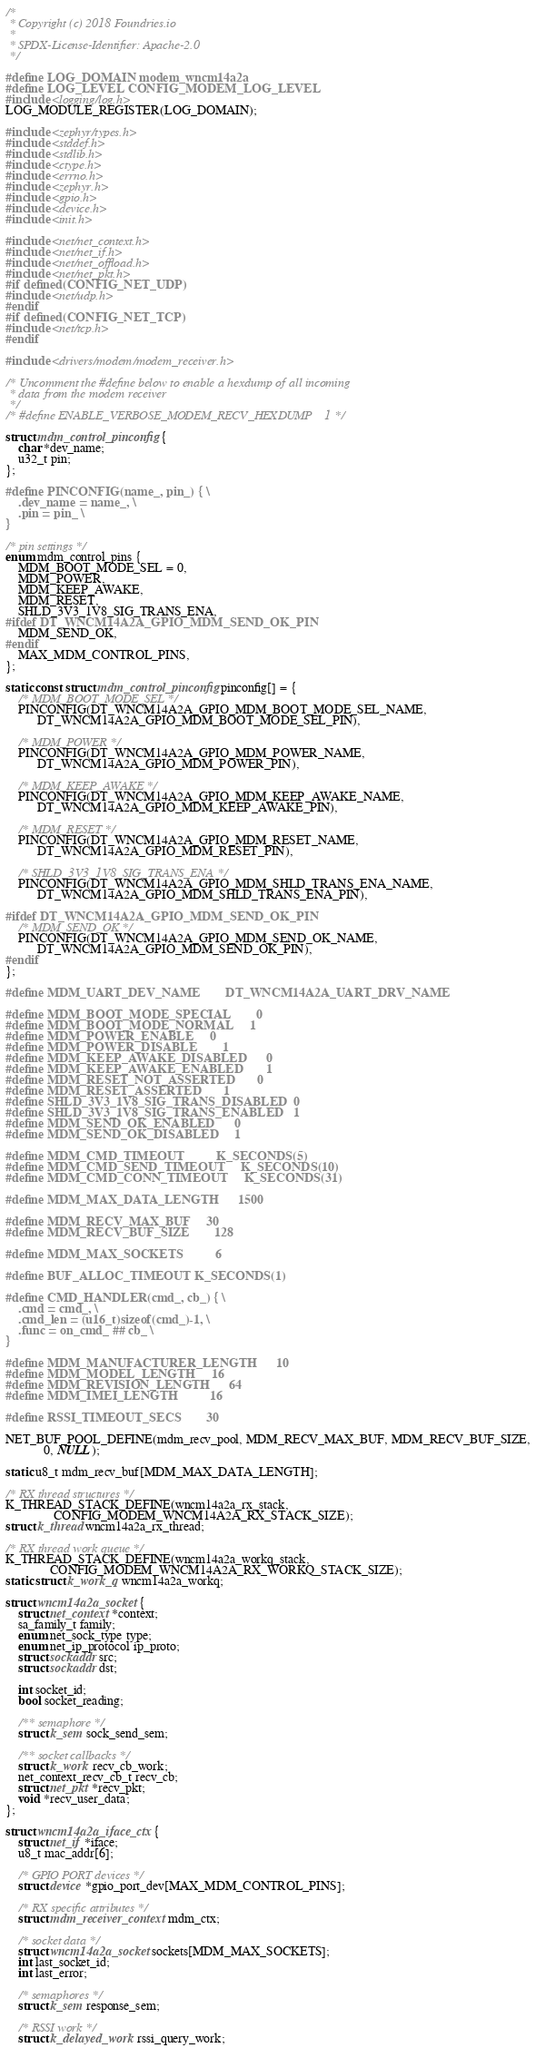Convert code to text. <code><loc_0><loc_0><loc_500><loc_500><_C_>/*
 * Copyright (c) 2018 Foundries.io
 *
 * SPDX-License-Identifier: Apache-2.0
 */

#define LOG_DOMAIN modem_wncm14a2a
#define LOG_LEVEL CONFIG_MODEM_LOG_LEVEL
#include <logging/log.h>
LOG_MODULE_REGISTER(LOG_DOMAIN);

#include <zephyr/types.h>
#include <stddef.h>
#include <stdlib.h>
#include <ctype.h>
#include <errno.h>
#include <zephyr.h>
#include <gpio.h>
#include <device.h>
#include <init.h>

#include <net/net_context.h>
#include <net/net_if.h>
#include <net/net_offload.h>
#include <net/net_pkt.h>
#if defined(CONFIG_NET_UDP)
#include <net/udp.h>
#endif
#if defined(CONFIG_NET_TCP)
#include <net/tcp.h>
#endif

#include <drivers/modem/modem_receiver.h>

/* Uncomment the #define below to enable a hexdump of all incoming
 * data from the modem receiver
 */
/* #define ENABLE_VERBOSE_MODEM_RECV_HEXDUMP	1 */

struct mdm_control_pinconfig {
	char *dev_name;
	u32_t pin;
};

#define PINCONFIG(name_, pin_) { \
	.dev_name = name_, \
	.pin = pin_ \
}

/* pin settings */
enum mdm_control_pins {
	MDM_BOOT_MODE_SEL = 0,
	MDM_POWER,
	MDM_KEEP_AWAKE,
	MDM_RESET,
	SHLD_3V3_1V8_SIG_TRANS_ENA,
#ifdef DT_WNCM14A2A_GPIO_MDM_SEND_OK_PIN
	MDM_SEND_OK,
#endif
	MAX_MDM_CONTROL_PINS,
};

static const struct mdm_control_pinconfig pinconfig[] = {
	/* MDM_BOOT_MODE_SEL */
	PINCONFIG(DT_WNCM14A2A_GPIO_MDM_BOOT_MODE_SEL_NAME,
		  DT_WNCM14A2A_GPIO_MDM_BOOT_MODE_SEL_PIN),

	/* MDM_POWER */
	PINCONFIG(DT_WNCM14A2A_GPIO_MDM_POWER_NAME,
		  DT_WNCM14A2A_GPIO_MDM_POWER_PIN),

	/* MDM_KEEP_AWAKE */
	PINCONFIG(DT_WNCM14A2A_GPIO_MDM_KEEP_AWAKE_NAME,
		  DT_WNCM14A2A_GPIO_MDM_KEEP_AWAKE_PIN),

	/* MDM_RESET */
	PINCONFIG(DT_WNCM14A2A_GPIO_MDM_RESET_NAME,
		  DT_WNCM14A2A_GPIO_MDM_RESET_PIN),

	/* SHLD_3V3_1V8_SIG_TRANS_ENA */
	PINCONFIG(DT_WNCM14A2A_GPIO_MDM_SHLD_TRANS_ENA_NAME,
		  DT_WNCM14A2A_GPIO_MDM_SHLD_TRANS_ENA_PIN),

#ifdef DT_WNCM14A2A_GPIO_MDM_SEND_OK_PIN
	/* MDM_SEND_OK */
	PINCONFIG(DT_WNCM14A2A_GPIO_MDM_SEND_OK_NAME,
		  DT_WNCM14A2A_GPIO_MDM_SEND_OK_PIN),
#endif
};

#define MDM_UART_DEV_NAME		DT_WNCM14A2A_UART_DRV_NAME

#define MDM_BOOT_MODE_SPECIAL		0
#define MDM_BOOT_MODE_NORMAL		1
#define MDM_POWER_ENABLE		0
#define MDM_POWER_DISABLE		1
#define MDM_KEEP_AWAKE_DISABLED		0
#define MDM_KEEP_AWAKE_ENABLED		1
#define MDM_RESET_NOT_ASSERTED		0
#define MDM_RESET_ASSERTED		1
#define SHLD_3V3_1V8_SIG_TRANS_DISABLED	0
#define SHLD_3V3_1V8_SIG_TRANS_ENABLED	1
#define MDM_SEND_OK_ENABLED		0
#define MDM_SEND_OK_DISABLED		1

#define MDM_CMD_TIMEOUT			K_SECONDS(5)
#define MDM_CMD_SEND_TIMEOUT		K_SECONDS(10)
#define MDM_CMD_CONN_TIMEOUT		K_SECONDS(31)

#define MDM_MAX_DATA_LENGTH		1500

#define MDM_RECV_MAX_BUF		30
#define MDM_RECV_BUF_SIZE		128

#define MDM_MAX_SOCKETS			6

#define BUF_ALLOC_TIMEOUT K_SECONDS(1)

#define CMD_HANDLER(cmd_, cb_) { \
	.cmd = cmd_, \
	.cmd_len = (u16_t)sizeof(cmd_)-1, \
	.func = on_cmd_ ## cb_ \
}

#define MDM_MANUFACTURER_LENGTH		10
#define MDM_MODEL_LENGTH		16
#define MDM_REVISION_LENGTH		64
#define MDM_IMEI_LENGTH			16

#define RSSI_TIMEOUT_SECS		30

NET_BUF_POOL_DEFINE(mdm_recv_pool, MDM_RECV_MAX_BUF, MDM_RECV_BUF_SIZE,
		    0, NULL);

static u8_t mdm_recv_buf[MDM_MAX_DATA_LENGTH];

/* RX thread structures */
K_THREAD_STACK_DEFINE(wncm14a2a_rx_stack,
		       CONFIG_MODEM_WNCM14A2A_RX_STACK_SIZE);
struct k_thread wncm14a2a_rx_thread;

/* RX thread work queue */
K_THREAD_STACK_DEFINE(wncm14a2a_workq_stack,
		      CONFIG_MODEM_WNCM14A2A_RX_WORKQ_STACK_SIZE);
static struct k_work_q wncm14a2a_workq;

struct wncm14a2a_socket {
	struct net_context *context;
	sa_family_t family;
	enum net_sock_type type;
	enum net_ip_protocol ip_proto;
	struct sockaddr src;
	struct sockaddr dst;

	int socket_id;
	bool socket_reading;

	/** semaphore */
	struct k_sem sock_send_sem;

	/** socket callbacks */
	struct k_work recv_cb_work;
	net_context_recv_cb_t recv_cb;
	struct net_pkt *recv_pkt;
	void *recv_user_data;
};

struct wncm14a2a_iface_ctx {
	struct net_if *iface;
	u8_t mac_addr[6];

	/* GPIO PORT devices */
	struct device *gpio_port_dev[MAX_MDM_CONTROL_PINS];

	/* RX specific attributes */
	struct mdm_receiver_context mdm_ctx;

	/* socket data */
	struct wncm14a2a_socket sockets[MDM_MAX_SOCKETS];
	int last_socket_id;
	int last_error;

	/* semaphores */
	struct k_sem response_sem;

	/* RSSI work */
	struct k_delayed_work rssi_query_work;
</code> 